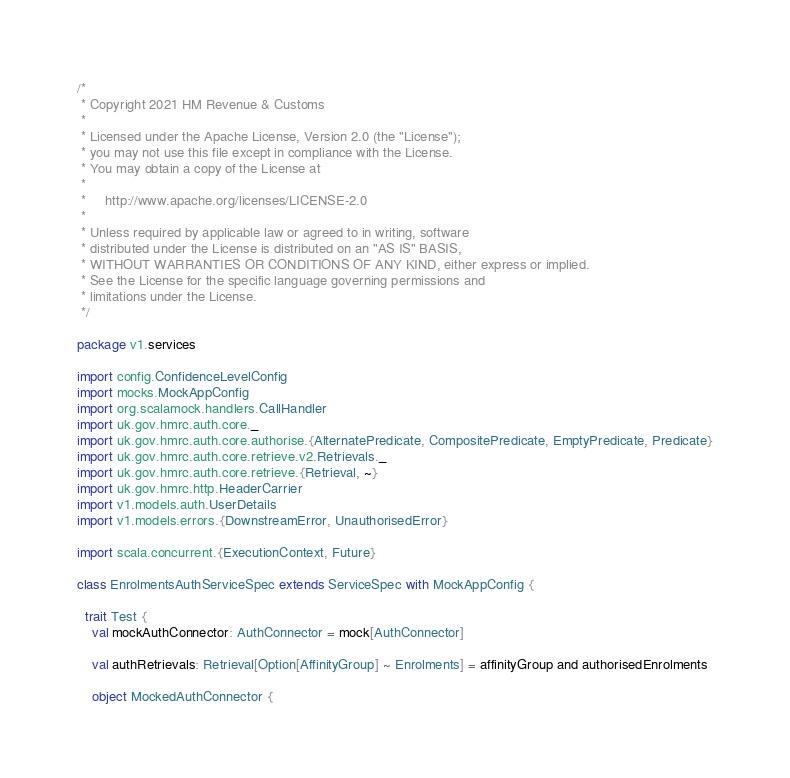<code> <loc_0><loc_0><loc_500><loc_500><_Scala_>/*
 * Copyright 2021 HM Revenue & Customs
 *
 * Licensed under the Apache License, Version 2.0 (the "License");
 * you may not use this file except in compliance with the License.
 * You may obtain a copy of the License at
 *
 *     http://www.apache.org/licenses/LICENSE-2.0
 *
 * Unless required by applicable law or agreed to in writing, software
 * distributed under the License is distributed on an "AS IS" BASIS,
 * WITHOUT WARRANTIES OR CONDITIONS OF ANY KIND, either express or implied.
 * See the License for the specific language governing permissions and
 * limitations under the License.
 */

package v1.services

import config.ConfidenceLevelConfig
import mocks.MockAppConfig
import org.scalamock.handlers.CallHandler
import uk.gov.hmrc.auth.core._
import uk.gov.hmrc.auth.core.authorise.{AlternatePredicate, CompositePredicate, EmptyPredicate, Predicate}
import uk.gov.hmrc.auth.core.retrieve.v2.Retrievals._
import uk.gov.hmrc.auth.core.retrieve.{Retrieval, ~}
import uk.gov.hmrc.http.HeaderCarrier
import v1.models.auth.UserDetails
import v1.models.errors.{DownstreamError, UnauthorisedError}

import scala.concurrent.{ExecutionContext, Future}

class EnrolmentsAuthServiceSpec extends ServiceSpec with MockAppConfig {

  trait Test {
    val mockAuthConnector: AuthConnector = mock[AuthConnector]

    val authRetrievals: Retrieval[Option[AffinityGroup] ~ Enrolments] = affinityGroup and authorisedEnrolments

    object MockedAuthConnector {</code> 